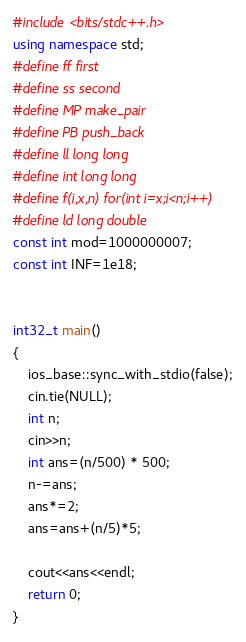<code> <loc_0><loc_0><loc_500><loc_500><_C++_>#include <bits/stdc++.h>
using namespace std;
#define ff first
#define ss second
#define MP make_pair
#define PB push_back
#define ll long long
#define int long long
#define f(i,x,n) for(int i=x;i<n;i++)
#define ld long double
const int mod=1000000007;
const int INF=1e18;


int32_t main()
{
    ios_base::sync_with_stdio(false);
    cin.tie(NULL);
    int n;
    cin>>n;
    int ans=(n/500) * 500;
    n-=ans;
    ans*=2;
    ans=ans+(n/5)*5;
    
    cout<<ans<<endl;
    return 0;
}</code> 